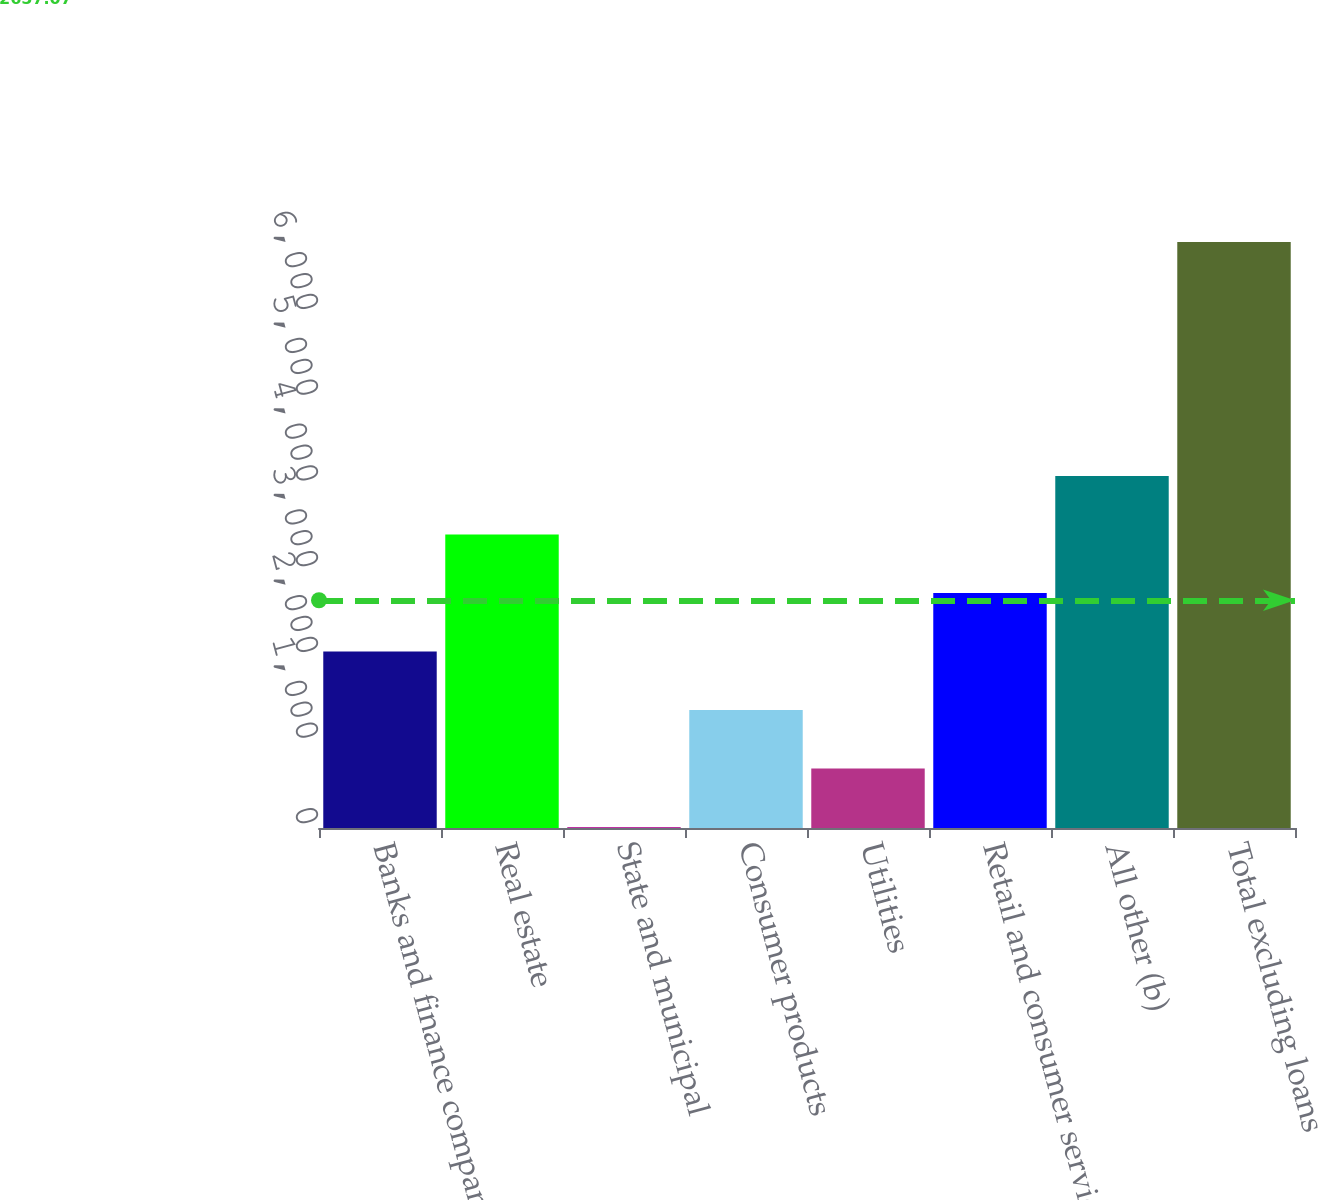Convert chart. <chart><loc_0><loc_0><loc_500><loc_500><bar_chart><fcel>Banks and finance companies<fcel>Real estate<fcel>State and municipal<fcel>Consumer products<fcel>Utilities<fcel>Retail and consumer services<fcel>All other (b)<fcel>Total excluding loans<nl><fcel>2059.8<fcel>3425<fcel>12<fcel>1377.2<fcel>694.6<fcel>2742.4<fcel>4107.6<fcel>6838<nl></chart> 